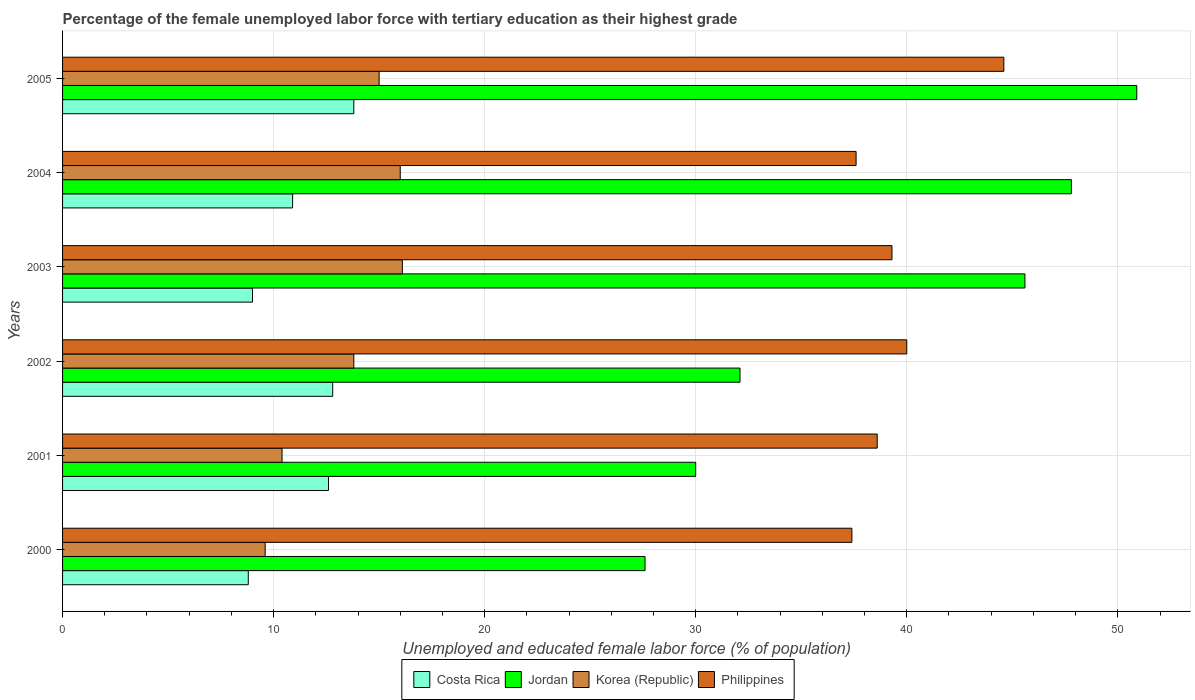How many different coloured bars are there?
Provide a short and direct response. 4. Are the number of bars per tick equal to the number of legend labels?
Your answer should be very brief. Yes. Are the number of bars on each tick of the Y-axis equal?
Your answer should be very brief. Yes. How many bars are there on the 4th tick from the top?
Keep it short and to the point. 4. How many bars are there on the 5th tick from the bottom?
Offer a very short reply. 4. What is the percentage of the unemployed female labor force with tertiary education in Philippines in 2003?
Your answer should be very brief. 39.3. Across all years, what is the maximum percentage of the unemployed female labor force with tertiary education in Korea (Republic)?
Ensure brevity in your answer.  16.1. Across all years, what is the minimum percentage of the unemployed female labor force with tertiary education in Korea (Republic)?
Ensure brevity in your answer.  9.6. In which year was the percentage of the unemployed female labor force with tertiary education in Philippines minimum?
Your answer should be compact. 2000. What is the total percentage of the unemployed female labor force with tertiary education in Korea (Republic) in the graph?
Keep it short and to the point. 80.9. What is the difference between the percentage of the unemployed female labor force with tertiary education in Costa Rica in 2001 and that in 2002?
Ensure brevity in your answer.  -0.2. What is the difference between the percentage of the unemployed female labor force with tertiary education in Jordan in 2003 and the percentage of the unemployed female labor force with tertiary education in Costa Rica in 2002?
Your response must be concise. 32.8. What is the average percentage of the unemployed female labor force with tertiary education in Costa Rica per year?
Provide a short and direct response. 11.32. In the year 2004, what is the difference between the percentage of the unemployed female labor force with tertiary education in Korea (Republic) and percentage of the unemployed female labor force with tertiary education in Costa Rica?
Offer a very short reply. 5.1. In how many years, is the percentage of the unemployed female labor force with tertiary education in Korea (Republic) greater than 20 %?
Give a very brief answer. 0. What is the ratio of the percentage of the unemployed female labor force with tertiary education in Jordan in 2003 to that in 2004?
Make the answer very short. 0.95. Is the percentage of the unemployed female labor force with tertiary education in Costa Rica in 2000 less than that in 2003?
Give a very brief answer. Yes. Is the difference between the percentage of the unemployed female labor force with tertiary education in Korea (Republic) in 2001 and 2005 greater than the difference between the percentage of the unemployed female labor force with tertiary education in Costa Rica in 2001 and 2005?
Offer a terse response. No. What is the difference between the highest and the second highest percentage of the unemployed female labor force with tertiary education in Jordan?
Your answer should be compact. 3.1. What is the difference between the highest and the lowest percentage of the unemployed female labor force with tertiary education in Costa Rica?
Ensure brevity in your answer.  5. Is the sum of the percentage of the unemployed female labor force with tertiary education in Korea (Republic) in 2001 and 2004 greater than the maximum percentage of the unemployed female labor force with tertiary education in Philippines across all years?
Offer a very short reply. No. Is it the case that in every year, the sum of the percentage of the unemployed female labor force with tertiary education in Philippines and percentage of the unemployed female labor force with tertiary education in Costa Rica is greater than the sum of percentage of the unemployed female labor force with tertiary education in Korea (Republic) and percentage of the unemployed female labor force with tertiary education in Jordan?
Offer a terse response. Yes. What does the 4th bar from the top in 2001 represents?
Give a very brief answer. Costa Rica. What does the 2nd bar from the bottom in 2000 represents?
Provide a succinct answer. Jordan. Are all the bars in the graph horizontal?
Keep it short and to the point. Yes. How many years are there in the graph?
Provide a succinct answer. 6. Are the values on the major ticks of X-axis written in scientific E-notation?
Keep it short and to the point. No. How many legend labels are there?
Offer a very short reply. 4. What is the title of the graph?
Offer a very short reply. Percentage of the female unemployed labor force with tertiary education as their highest grade. Does "Marshall Islands" appear as one of the legend labels in the graph?
Your answer should be very brief. No. What is the label or title of the X-axis?
Keep it short and to the point. Unemployed and educated female labor force (% of population). What is the label or title of the Y-axis?
Ensure brevity in your answer.  Years. What is the Unemployed and educated female labor force (% of population) of Costa Rica in 2000?
Ensure brevity in your answer.  8.8. What is the Unemployed and educated female labor force (% of population) of Jordan in 2000?
Your response must be concise. 27.6. What is the Unemployed and educated female labor force (% of population) of Korea (Republic) in 2000?
Offer a very short reply. 9.6. What is the Unemployed and educated female labor force (% of population) of Philippines in 2000?
Keep it short and to the point. 37.4. What is the Unemployed and educated female labor force (% of population) in Costa Rica in 2001?
Make the answer very short. 12.6. What is the Unemployed and educated female labor force (% of population) in Jordan in 2001?
Offer a terse response. 30. What is the Unemployed and educated female labor force (% of population) in Korea (Republic) in 2001?
Offer a very short reply. 10.4. What is the Unemployed and educated female labor force (% of population) in Philippines in 2001?
Provide a succinct answer. 38.6. What is the Unemployed and educated female labor force (% of population) of Costa Rica in 2002?
Offer a very short reply. 12.8. What is the Unemployed and educated female labor force (% of population) in Jordan in 2002?
Ensure brevity in your answer.  32.1. What is the Unemployed and educated female labor force (% of population) in Korea (Republic) in 2002?
Offer a terse response. 13.8. What is the Unemployed and educated female labor force (% of population) of Philippines in 2002?
Your response must be concise. 40. What is the Unemployed and educated female labor force (% of population) of Costa Rica in 2003?
Provide a succinct answer. 9. What is the Unemployed and educated female labor force (% of population) in Jordan in 2003?
Provide a short and direct response. 45.6. What is the Unemployed and educated female labor force (% of population) of Korea (Republic) in 2003?
Keep it short and to the point. 16.1. What is the Unemployed and educated female labor force (% of population) in Philippines in 2003?
Your response must be concise. 39.3. What is the Unemployed and educated female labor force (% of population) in Costa Rica in 2004?
Keep it short and to the point. 10.9. What is the Unemployed and educated female labor force (% of population) of Jordan in 2004?
Offer a very short reply. 47.8. What is the Unemployed and educated female labor force (% of population) of Philippines in 2004?
Your answer should be compact. 37.6. What is the Unemployed and educated female labor force (% of population) of Costa Rica in 2005?
Give a very brief answer. 13.8. What is the Unemployed and educated female labor force (% of population) in Jordan in 2005?
Give a very brief answer. 50.9. What is the Unemployed and educated female labor force (% of population) in Korea (Republic) in 2005?
Give a very brief answer. 15. What is the Unemployed and educated female labor force (% of population) of Philippines in 2005?
Keep it short and to the point. 44.6. Across all years, what is the maximum Unemployed and educated female labor force (% of population) of Costa Rica?
Keep it short and to the point. 13.8. Across all years, what is the maximum Unemployed and educated female labor force (% of population) in Jordan?
Provide a short and direct response. 50.9. Across all years, what is the maximum Unemployed and educated female labor force (% of population) in Korea (Republic)?
Ensure brevity in your answer.  16.1. Across all years, what is the maximum Unemployed and educated female labor force (% of population) of Philippines?
Offer a very short reply. 44.6. Across all years, what is the minimum Unemployed and educated female labor force (% of population) in Costa Rica?
Your answer should be very brief. 8.8. Across all years, what is the minimum Unemployed and educated female labor force (% of population) in Jordan?
Your answer should be very brief. 27.6. Across all years, what is the minimum Unemployed and educated female labor force (% of population) of Korea (Republic)?
Make the answer very short. 9.6. Across all years, what is the minimum Unemployed and educated female labor force (% of population) of Philippines?
Make the answer very short. 37.4. What is the total Unemployed and educated female labor force (% of population) of Costa Rica in the graph?
Your answer should be very brief. 67.9. What is the total Unemployed and educated female labor force (% of population) in Jordan in the graph?
Your answer should be compact. 234. What is the total Unemployed and educated female labor force (% of population) in Korea (Republic) in the graph?
Your response must be concise. 80.9. What is the total Unemployed and educated female labor force (% of population) in Philippines in the graph?
Keep it short and to the point. 237.5. What is the difference between the Unemployed and educated female labor force (% of population) of Costa Rica in 2000 and that in 2001?
Provide a short and direct response. -3.8. What is the difference between the Unemployed and educated female labor force (% of population) of Jordan in 2000 and that in 2001?
Make the answer very short. -2.4. What is the difference between the Unemployed and educated female labor force (% of population) in Korea (Republic) in 2000 and that in 2001?
Ensure brevity in your answer.  -0.8. What is the difference between the Unemployed and educated female labor force (% of population) in Philippines in 2000 and that in 2001?
Ensure brevity in your answer.  -1.2. What is the difference between the Unemployed and educated female labor force (% of population) of Costa Rica in 2000 and that in 2002?
Your response must be concise. -4. What is the difference between the Unemployed and educated female labor force (% of population) in Jordan in 2000 and that in 2002?
Keep it short and to the point. -4.5. What is the difference between the Unemployed and educated female labor force (% of population) in Korea (Republic) in 2000 and that in 2002?
Your answer should be very brief. -4.2. What is the difference between the Unemployed and educated female labor force (% of population) of Philippines in 2000 and that in 2002?
Give a very brief answer. -2.6. What is the difference between the Unemployed and educated female labor force (% of population) in Jordan in 2000 and that in 2003?
Your response must be concise. -18. What is the difference between the Unemployed and educated female labor force (% of population) of Philippines in 2000 and that in 2003?
Your answer should be very brief. -1.9. What is the difference between the Unemployed and educated female labor force (% of population) of Costa Rica in 2000 and that in 2004?
Offer a very short reply. -2.1. What is the difference between the Unemployed and educated female labor force (% of population) in Jordan in 2000 and that in 2004?
Provide a short and direct response. -20.2. What is the difference between the Unemployed and educated female labor force (% of population) in Jordan in 2000 and that in 2005?
Keep it short and to the point. -23.3. What is the difference between the Unemployed and educated female labor force (% of population) in Korea (Republic) in 2000 and that in 2005?
Provide a succinct answer. -5.4. What is the difference between the Unemployed and educated female labor force (% of population) of Philippines in 2000 and that in 2005?
Give a very brief answer. -7.2. What is the difference between the Unemployed and educated female labor force (% of population) of Jordan in 2001 and that in 2003?
Ensure brevity in your answer.  -15.6. What is the difference between the Unemployed and educated female labor force (% of population) of Korea (Republic) in 2001 and that in 2003?
Offer a very short reply. -5.7. What is the difference between the Unemployed and educated female labor force (% of population) in Costa Rica in 2001 and that in 2004?
Your answer should be compact. 1.7. What is the difference between the Unemployed and educated female labor force (% of population) of Jordan in 2001 and that in 2004?
Ensure brevity in your answer.  -17.8. What is the difference between the Unemployed and educated female labor force (% of population) of Korea (Republic) in 2001 and that in 2004?
Your answer should be compact. -5.6. What is the difference between the Unemployed and educated female labor force (% of population) of Costa Rica in 2001 and that in 2005?
Provide a succinct answer. -1.2. What is the difference between the Unemployed and educated female labor force (% of population) in Jordan in 2001 and that in 2005?
Ensure brevity in your answer.  -20.9. What is the difference between the Unemployed and educated female labor force (% of population) in Philippines in 2001 and that in 2005?
Provide a succinct answer. -6. What is the difference between the Unemployed and educated female labor force (% of population) in Costa Rica in 2002 and that in 2003?
Your answer should be compact. 3.8. What is the difference between the Unemployed and educated female labor force (% of population) of Korea (Republic) in 2002 and that in 2003?
Your response must be concise. -2.3. What is the difference between the Unemployed and educated female labor force (% of population) in Philippines in 2002 and that in 2003?
Your response must be concise. 0.7. What is the difference between the Unemployed and educated female labor force (% of population) of Jordan in 2002 and that in 2004?
Provide a short and direct response. -15.7. What is the difference between the Unemployed and educated female labor force (% of population) in Korea (Republic) in 2002 and that in 2004?
Your answer should be very brief. -2.2. What is the difference between the Unemployed and educated female labor force (% of population) in Philippines in 2002 and that in 2004?
Provide a short and direct response. 2.4. What is the difference between the Unemployed and educated female labor force (% of population) in Costa Rica in 2002 and that in 2005?
Offer a terse response. -1. What is the difference between the Unemployed and educated female labor force (% of population) of Jordan in 2002 and that in 2005?
Provide a short and direct response. -18.8. What is the difference between the Unemployed and educated female labor force (% of population) in Philippines in 2002 and that in 2005?
Offer a very short reply. -4.6. What is the difference between the Unemployed and educated female labor force (% of population) in Costa Rica in 2003 and that in 2004?
Offer a very short reply. -1.9. What is the difference between the Unemployed and educated female labor force (% of population) of Jordan in 2003 and that in 2004?
Offer a very short reply. -2.2. What is the difference between the Unemployed and educated female labor force (% of population) in Korea (Republic) in 2003 and that in 2005?
Ensure brevity in your answer.  1.1. What is the difference between the Unemployed and educated female labor force (% of population) of Philippines in 2003 and that in 2005?
Provide a succinct answer. -5.3. What is the difference between the Unemployed and educated female labor force (% of population) of Philippines in 2004 and that in 2005?
Make the answer very short. -7. What is the difference between the Unemployed and educated female labor force (% of population) in Costa Rica in 2000 and the Unemployed and educated female labor force (% of population) in Jordan in 2001?
Offer a terse response. -21.2. What is the difference between the Unemployed and educated female labor force (% of population) of Costa Rica in 2000 and the Unemployed and educated female labor force (% of population) of Korea (Republic) in 2001?
Your answer should be very brief. -1.6. What is the difference between the Unemployed and educated female labor force (% of population) of Costa Rica in 2000 and the Unemployed and educated female labor force (% of population) of Philippines in 2001?
Your response must be concise. -29.8. What is the difference between the Unemployed and educated female labor force (% of population) in Korea (Republic) in 2000 and the Unemployed and educated female labor force (% of population) in Philippines in 2001?
Offer a very short reply. -29. What is the difference between the Unemployed and educated female labor force (% of population) of Costa Rica in 2000 and the Unemployed and educated female labor force (% of population) of Jordan in 2002?
Keep it short and to the point. -23.3. What is the difference between the Unemployed and educated female labor force (% of population) in Costa Rica in 2000 and the Unemployed and educated female labor force (% of population) in Korea (Republic) in 2002?
Keep it short and to the point. -5. What is the difference between the Unemployed and educated female labor force (% of population) of Costa Rica in 2000 and the Unemployed and educated female labor force (% of population) of Philippines in 2002?
Provide a succinct answer. -31.2. What is the difference between the Unemployed and educated female labor force (% of population) in Korea (Republic) in 2000 and the Unemployed and educated female labor force (% of population) in Philippines in 2002?
Give a very brief answer. -30.4. What is the difference between the Unemployed and educated female labor force (% of population) of Costa Rica in 2000 and the Unemployed and educated female labor force (% of population) of Jordan in 2003?
Offer a terse response. -36.8. What is the difference between the Unemployed and educated female labor force (% of population) in Costa Rica in 2000 and the Unemployed and educated female labor force (% of population) in Philippines in 2003?
Provide a succinct answer. -30.5. What is the difference between the Unemployed and educated female labor force (% of population) in Jordan in 2000 and the Unemployed and educated female labor force (% of population) in Philippines in 2003?
Keep it short and to the point. -11.7. What is the difference between the Unemployed and educated female labor force (% of population) in Korea (Republic) in 2000 and the Unemployed and educated female labor force (% of population) in Philippines in 2003?
Provide a short and direct response. -29.7. What is the difference between the Unemployed and educated female labor force (% of population) in Costa Rica in 2000 and the Unemployed and educated female labor force (% of population) in Jordan in 2004?
Make the answer very short. -39. What is the difference between the Unemployed and educated female labor force (% of population) in Costa Rica in 2000 and the Unemployed and educated female labor force (% of population) in Korea (Republic) in 2004?
Your answer should be very brief. -7.2. What is the difference between the Unemployed and educated female labor force (% of population) of Costa Rica in 2000 and the Unemployed and educated female labor force (% of population) of Philippines in 2004?
Your response must be concise. -28.8. What is the difference between the Unemployed and educated female labor force (% of population) of Korea (Republic) in 2000 and the Unemployed and educated female labor force (% of population) of Philippines in 2004?
Your answer should be compact. -28. What is the difference between the Unemployed and educated female labor force (% of population) of Costa Rica in 2000 and the Unemployed and educated female labor force (% of population) of Jordan in 2005?
Provide a short and direct response. -42.1. What is the difference between the Unemployed and educated female labor force (% of population) in Costa Rica in 2000 and the Unemployed and educated female labor force (% of population) in Korea (Republic) in 2005?
Ensure brevity in your answer.  -6.2. What is the difference between the Unemployed and educated female labor force (% of population) of Costa Rica in 2000 and the Unemployed and educated female labor force (% of population) of Philippines in 2005?
Give a very brief answer. -35.8. What is the difference between the Unemployed and educated female labor force (% of population) in Jordan in 2000 and the Unemployed and educated female labor force (% of population) in Korea (Republic) in 2005?
Ensure brevity in your answer.  12.6. What is the difference between the Unemployed and educated female labor force (% of population) in Jordan in 2000 and the Unemployed and educated female labor force (% of population) in Philippines in 2005?
Keep it short and to the point. -17. What is the difference between the Unemployed and educated female labor force (% of population) in Korea (Republic) in 2000 and the Unemployed and educated female labor force (% of population) in Philippines in 2005?
Make the answer very short. -35. What is the difference between the Unemployed and educated female labor force (% of population) of Costa Rica in 2001 and the Unemployed and educated female labor force (% of population) of Jordan in 2002?
Ensure brevity in your answer.  -19.5. What is the difference between the Unemployed and educated female labor force (% of population) of Costa Rica in 2001 and the Unemployed and educated female labor force (% of population) of Korea (Republic) in 2002?
Keep it short and to the point. -1.2. What is the difference between the Unemployed and educated female labor force (% of population) in Costa Rica in 2001 and the Unemployed and educated female labor force (% of population) in Philippines in 2002?
Offer a terse response. -27.4. What is the difference between the Unemployed and educated female labor force (% of population) of Jordan in 2001 and the Unemployed and educated female labor force (% of population) of Philippines in 2002?
Offer a terse response. -10. What is the difference between the Unemployed and educated female labor force (% of population) in Korea (Republic) in 2001 and the Unemployed and educated female labor force (% of population) in Philippines in 2002?
Your answer should be compact. -29.6. What is the difference between the Unemployed and educated female labor force (% of population) in Costa Rica in 2001 and the Unemployed and educated female labor force (% of population) in Jordan in 2003?
Ensure brevity in your answer.  -33. What is the difference between the Unemployed and educated female labor force (% of population) in Costa Rica in 2001 and the Unemployed and educated female labor force (% of population) in Korea (Republic) in 2003?
Offer a very short reply. -3.5. What is the difference between the Unemployed and educated female labor force (% of population) of Costa Rica in 2001 and the Unemployed and educated female labor force (% of population) of Philippines in 2003?
Offer a very short reply. -26.7. What is the difference between the Unemployed and educated female labor force (% of population) of Korea (Republic) in 2001 and the Unemployed and educated female labor force (% of population) of Philippines in 2003?
Offer a terse response. -28.9. What is the difference between the Unemployed and educated female labor force (% of population) of Costa Rica in 2001 and the Unemployed and educated female labor force (% of population) of Jordan in 2004?
Offer a very short reply. -35.2. What is the difference between the Unemployed and educated female labor force (% of population) in Costa Rica in 2001 and the Unemployed and educated female labor force (% of population) in Korea (Republic) in 2004?
Offer a very short reply. -3.4. What is the difference between the Unemployed and educated female labor force (% of population) in Costa Rica in 2001 and the Unemployed and educated female labor force (% of population) in Philippines in 2004?
Give a very brief answer. -25. What is the difference between the Unemployed and educated female labor force (% of population) of Korea (Republic) in 2001 and the Unemployed and educated female labor force (% of population) of Philippines in 2004?
Provide a short and direct response. -27.2. What is the difference between the Unemployed and educated female labor force (% of population) of Costa Rica in 2001 and the Unemployed and educated female labor force (% of population) of Jordan in 2005?
Your answer should be compact. -38.3. What is the difference between the Unemployed and educated female labor force (% of population) of Costa Rica in 2001 and the Unemployed and educated female labor force (% of population) of Philippines in 2005?
Provide a short and direct response. -32. What is the difference between the Unemployed and educated female labor force (% of population) of Jordan in 2001 and the Unemployed and educated female labor force (% of population) of Philippines in 2005?
Keep it short and to the point. -14.6. What is the difference between the Unemployed and educated female labor force (% of population) of Korea (Republic) in 2001 and the Unemployed and educated female labor force (% of population) of Philippines in 2005?
Offer a terse response. -34.2. What is the difference between the Unemployed and educated female labor force (% of population) of Costa Rica in 2002 and the Unemployed and educated female labor force (% of population) of Jordan in 2003?
Make the answer very short. -32.8. What is the difference between the Unemployed and educated female labor force (% of population) of Costa Rica in 2002 and the Unemployed and educated female labor force (% of population) of Philippines in 2003?
Keep it short and to the point. -26.5. What is the difference between the Unemployed and educated female labor force (% of population) of Jordan in 2002 and the Unemployed and educated female labor force (% of population) of Korea (Republic) in 2003?
Offer a terse response. 16. What is the difference between the Unemployed and educated female labor force (% of population) in Jordan in 2002 and the Unemployed and educated female labor force (% of population) in Philippines in 2003?
Keep it short and to the point. -7.2. What is the difference between the Unemployed and educated female labor force (% of population) of Korea (Republic) in 2002 and the Unemployed and educated female labor force (% of population) of Philippines in 2003?
Your answer should be very brief. -25.5. What is the difference between the Unemployed and educated female labor force (% of population) of Costa Rica in 2002 and the Unemployed and educated female labor force (% of population) of Jordan in 2004?
Keep it short and to the point. -35. What is the difference between the Unemployed and educated female labor force (% of population) of Costa Rica in 2002 and the Unemployed and educated female labor force (% of population) of Philippines in 2004?
Your answer should be very brief. -24.8. What is the difference between the Unemployed and educated female labor force (% of population) of Jordan in 2002 and the Unemployed and educated female labor force (% of population) of Korea (Republic) in 2004?
Your answer should be very brief. 16.1. What is the difference between the Unemployed and educated female labor force (% of population) of Jordan in 2002 and the Unemployed and educated female labor force (% of population) of Philippines in 2004?
Give a very brief answer. -5.5. What is the difference between the Unemployed and educated female labor force (% of population) in Korea (Republic) in 2002 and the Unemployed and educated female labor force (% of population) in Philippines in 2004?
Provide a succinct answer. -23.8. What is the difference between the Unemployed and educated female labor force (% of population) of Costa Rica in 2002 and the Unemployed and educated female labor force (% of population) of Jordan in 2005?
Ensure brevity in your answer.  -38.1. What is the difference between the Unemployed and educated female labor force (% of population) of Costa Rica in 2002 and the Unemployed and educated female labor force (% of population) of Korea (Republic) in 2005?
Give a very brief answer. -2.2. What is the difference between the Unemployed and educated female labor force (% of population) of Costa Rica in 2002 and the Unemployed and educated female labor force (% of population) of Philippines in 2005?
Ensure brevity in your answer.  -31.8. What is the difference between the Unemployed and educated female labor force (% of population) in Korea (Republic) in 2002 and the Unemployed and educated female labor force (% of population) in Philippines in 2005?
Give a very brief answer. -30.8. What is the difference between the Unemployed and educated female labor force (% of population) in Costa Rica in 2003 and the Unemployed and educated female labor force (% of population) in Jordan in 2004?
Give a very brief answer. -38.8. What is the difference between the Unemployed and educated female labor force (% of population) of Costa Rica in 2003 and the Unemployed and educated female labor force (% of population) of Korea (Republic) in 2004?
Your answer should be very brief. -7. What is the difference between the Unemployed and educated female labor force (% of population) in Costa Rica in 2003 and the Unemployed and educated female labor force (% of population) in Philippines in 2004?
Your response must be concise. -28.6. What is the difference between the Unemployed and educated female labor force (% of population) of Jordan in 2003 and the Unemployed and educated female labor force (% of population) of Korea (Republic) in 2004?
Provide a short and direct response. 29.6. What is the difference between the Unemployed and educated female labor force (% of population) in Korea (Republic) in 2003 and the Unemployed and educated female labor force (% of population) in Philippines in 2004?
Your response must be concise. -21.5. What is the difference between the Unemployed and educated female labor force (% of population) of Costa Rica in 2003 and the Unemployed and educated female labor force (% of population) of Jordan in 2005?
Make the answer very short. -41.9. What is the difference between the Unemployed and educated female labor force (% of population) in Costa Rica in 2003 and the Unemployed and educated female labor force (% of population) in Philippines in 2005?
Make the answer very short. -35.6. What is the difference between the Unemployed and educated female labor force (% of population) in Jordan in 2003 and the Unemployed and educated female labor force (% of population) in Korea (Republic) in 2005?
Give a very brief answer. 30.6. What is the difference between the Unemployed and educated female labor force (% of population) of Jordan in 2003 and the Unemployed and educated female labor force (% of population) of Philippines in 2005?
Keep it short and to the point. 1. What is the difference between the Unemployed and educated female labor force (% of population) of Korea (Republic) in 2003 and the Unemployed and educated female labor force (% of population) of Philippines in 2005?
Keep it short and to the point. -28.5. What is the difference between the Unemployed and educated female labor force (% of population) of Costa Rica in 2004 and the Unemployed and educated female labor force (% of population) of Jordan in 2005?
Keep it short and to the point. -40. What is the difference between the Unemployed and educated female labor force (% of population) of Costa Rica in 2004 and the Unemployed and educated female labor force (% of population) of Korea (Republic) in 2005?
Give a very brief answer. -4.1. What is the difference between the Unemployed and educated female labor force (% of population) of Costa Rica in 2004 and the Unemployed and educated female labor force (% of population) of Philippines in 2005?
Your response must be concise. -33.7. What is the difference between the Unemployed and educated female labor force (% of population) of Jordan in 2004 and the Unemployed and educated female labor force (% of population) of Korea (Republic) in 2005?
Offer a terse response. 32.8. What is the difference between the Unemployed and educated female labor force (% of population) of Jordan in 2004 and the Unemployed and educated female labor force (% of population) of Philippines in 2005?
Provide a succinct answer. 3.2. What is the difference between the Unemployed and educated female labor force (% of population) in Korea (Republic) in 2004 and the Unemployed and educated female labor force (% of population) in Philippines in 2005?
Provide a short and direct response. -28.6. What is the average Unemployed and educated female labor force (% of population) in Costa Rica per year?
Keep it short and to the point. 11.32. What is the average Unemployed and educated female labor force (% of population) in Jordan per year?
Your answer should be compact. 39. What is the average Unemployed and educated female labor force (% of population) in Korea (Republic) per year?
Give a very brief answer. 13.48. What is the average Unemployed and educated female labor force (% of population) in Philippines per year?
Provide a short and direct response. 39.58. In the year 2000, what is the difference between the Unemployed and educated female labor force (% of population) in Costa Rica and Unemployed and educated female labor force (% of population) in Jordan?
Keep it short and to the point. -18.8. In the year 2000, what is the difference between the Unemployed and educated female labor force (% of population) of Costa Rica and Unemployed and educated female labor force (% of population) of Philippines?
Provide a short and direct response. -28.6. In the year 2000, what is the difference between the Unemployed and educated female labor force (% of population) in Jordan and Unemployed and educated female labor force (% of population) in Philippines?
Make the answer very short. -9.8. In the year 2000, what is the difference between the Unemployed and educated female labor force (% of population) in Korea (Republic) and Unemployed and educated female labor force (% of population) in Philippines?
Ensure brevity in your answer.  -27.8. In the year 2001, what is the difference between the Unemployed and educated female labor force (% of population) in Costa Rica and Unemployed and educated female labor force (% of population) in Jordan?
Your answer should be very brief. -17.4. In the year 2001, what is the difference between the Unemployed and educated female labor force (% of population) of Costa Rica and Unemployed and educated female labor force (% of population) of Korea (Republic)?
Give a very brief answer. 2.2. In the year 2001, what is the difference between the Unemployed and educated female labor force (% of population) in Costa Rica and Unemployed and educated female labor force (% of population) in Philippines?
Keep it short and to the point. -26. In the year 2001, what is the difference between the Unemployed and educated female labor force (% of population) of Jordan and Unemployed and educated female labor force (% of population) of Korea (Republic)?
Your response must be concise. 19.6. In the year 2001, what is the difference between the Unemployed and educated female labor force (% of population) of Jordan and Unemployed and educated female labor force (% of population) of Philippines?
Your answer should be very brief. -8.6. In the year 2001, what is the difference between the Unemployed and educated female labor force (% of population) of Korea (Republic) and Unemployed and educated female labor force (% of population) of Philippines?
Offer a very short reply. -28.2. In the year 2002, what is the difference between the Unemployed and educated female labor force (% of population) of Costa Rica and Unemployed and educated female labor force (% of population) of Jordan?
Provide a short and direct response. -19.3. In the year 2002, what is the difference between the Unemployed and educated female labor force (% of population) in Costa Rica and Unemployed and educated female labor force (% of population) in Philippines?
Make the answer very short. -27.2. In the year 2002, what is the difference between the Unemployed and educated female labor force (% of population) in Jordan and Unemployed and educated female labor force (% of population) in Philippines?
Your answer should be compact. -7.9. In the year 2002, what is the difference between the Unemployed and educated female labor force (% of population) in Korea (Republic) and Unemployed and educated female labor force (% of population) in Philippines?
Make the answer very short. -26.2. In the year 2003, what is the difference between the Unemployed and educated female labor force (% of population) in Costa Rica and Unemployed and educated female labor force (% of population) in Jordan?
Offer a very short reply. -36.6. In the year 2003, what is the difference between the Unemployed and educated female labor force (% of population) of Costa Rica and Unemployed and educated female labor force (% of population) of Korea (Republic)?
Make the answer very short. -7.1. In the year 2003, what is the difference between the Unemployed and educated female labor force (% of population) of Costa Rica and Unemployed and educated female labor force (% of population) of Philippines?
Your response must be concise. -30.3. In the year 2003, what is the difference between the Unemployed and educated female labor force (% of population) in Jordan and Unemployed and educated female labor force (% of population) in Korea (Republic)?
Ensure brevity in your answer.  29.5. In the year 2003, what is the difference between the Unemployed and educated female labor force (% of population) of Korea (Republic) and Unemployed and educated female labor force (% of population) of Philippines?
Your answer should be very brief. -23.2. In the year 2004, what is the difference between the Unemployed and educated female labor force (% of population) of Costa Rica and Unemployed and educated female labor force (% of population) of Jordan?
Your answer should be very brief. -36.9. In the year 2004, what is the difference between the Unemployed and educated female labor force (% of population) in Costa Rica and Unemployed and educated female labor force (% of population) in Korea (Republic)?
Offer a terse response. -5.1. In the year 2004, what is the difference between the Unemployed and educated female labor force (% of population) in Costa Rica and Unemployed and educated female labor force (% of population) in Philippines?
Ensure brevity in your answer.  -26.7. In the year 2004, what is the difference between the Unemployed and educated female labor force (% of population) of Jordan and Unemployed and educated female labor force (% of population) of Korea (Republic)?
Your answer should be very brief. 31.8. In the year 2004, what is the difference between the Unemployed and educated female labor force (% of population) of Jordan and Unemployed and educated female labor force (% of population) of Philippines?
Ensure brevity in your answer.  10.2. In the year 2004, what is the difference between the Unemployed and educated female labor force (% of population) of Korea (Republic) and Unemployed and educated female labor force (% of population) of Philippines?
Make the answer very short. -21.6. In the year 2005, what is the difference between the Unemployed and educated female labor force (% of population) of Costa Rica and Unemployed and educated female labor force (% of population) of Jordan?
Make the answer very short. -37.1. In the year 2005, what is the difference between the Unemployed and educated female labor force (% of population) of Costa Rica and Unemployed and educated female labor force (% of population) of Korea (Republic)?
Make the answer very short. -1.2. In the year 2005, what is the difference between the Unemployed and educated female labor force (% of population) of Costa Rica and Unemployed and educated female labor force (% of population) of Philippines?
Offer a very short reply. -30.8. In the year 2005, what is the difference between the Unemployed and educated female labor force (% of population) of Jordan and Unemployed and educated female labor force (% of population) of Korea (Republic)?
Provide a short and direct response. 35.9. In the year 2005, what is the difference between the Unemployed and educated female labor force (% of population) in Korea (Republic) and Unemployed and educated female labor force (% of population) in Philippines?
Provide a short and direct response. -29.6. What is the ratio of the Unemployed and educated female labor force (% of population) of Costa Rica in 2000 to that in 2001?
Provide a short and direct response. 0.7. What is the ratio of the Unemployed and educated female labor force (% of population) in Philippines in 2000 to that in 2001?
Provide a short and direct response. 0.97. What is the ratio of the Unemployed and educated female labor force (% of population) in Costa Rica in 2000 to that in 2002?
Offer a very short reply. 0.69. What is the ratio of the Unemployed and educated female labor force (% of population) of Jordan in 2000 to that in 2002?
Make the answer very short. 0.86. What is the ratio of the Unemployed and educated female labor force (% of population) of Korea (Republic) in 2000 to that in 2002?
Provide a succinct answer. 0.7. What is the ratio of the Unemployed and educated female labor force (% of population) in Philippines in 2000 to that in 2002?
Ensure brevity in your answer.  0.94. What is the ratio of the Unemployed and educated female labor force (% of population) of Costa Rica in 2000 to that in 2003?
Provide a succinct answer. 0.98. What is the ratio of the Unemployed and educated female labor force (% of population) of Jordan in 2000 to that in 2003?
Make the answer very short. 0.61. What is the ratio of the Unemployed and educated female labor force (% of population) in Korea (Republic) in 2000 to that in 2003?
Make the answer very short. 0.6. What is the ratio of the Unemployed and educated female labor force (% of population) of Philippines in 2000 to that in 2003?
Provide a succinct answer. 0.95. What is the ratio of the Unemployed and educated female labor force (% of population) of Costa Rica in 2000 to that in 2004?
Make the answer very short. 0.81. What is the ratio of the Unemployed and educated female labor force (% of population) of Jordan in 2000 to that in 2004?
Make the answer very short. 0.58. What is the ratio of the Unemployed and educated female labor force (% of population) of Costa Rica in 2000 to that in 2005?
Keep it short and to the point. 0.64. What is the ratio of the Unemployed and educated female labor force (% of population) in Jordan in 2000 to that in 2005?
Provide a short and direct response. 0.54. What is the ratio of the Unemployed and educated female labor force (% of population) in Korea (Republic) in 2000 to that in 2005?
Ensure brevity in your answer.  0.64. What is the ratio of the Unemployed and educated female labor force (% of population) in Philippines in 2000 to that in 2005?
Ensure brevity in your answer.  0.84. What is the ratio of the Unemployed and educated female labor force (% of population) in Costa Rica in 2001 to that in 2002?
Your answer should be compact. 0.98. What is the ratio of the Unemployed and educated female labor force (% of population) in Jordan in 2001 to that in 2002?
Your response must be concise. 0.93. What is the ratio of the Unemployed and educated female labor force (% of population) in Korea (Republic) in 2001 to that in 2002?
Offer a very short reply. 0.75. What is the ratio of the Unemployed and educated female labor force (% of population) of Jordan in 2001 to that in 2003?
Provide a succinct answer. 0.66. What is the ratio of the Unemployed and educated female labor force (% of population) in Korea (Republic) in 2001 to that in 2003?
Offer a terse response. 0.65. What is the ratio of the Unemployed and educated female labor force (% of population) in Philippines in 2001 to that in 2003?
Give a very brief answer. 0.98. What is the ratio of the Unemployed and educated female labor force (% of population) of Costa Rica in 2001 to that in 2004?
Offer a very short reply. 1.16. What is the ratio of the Unemployed and educated female labor force (% of population) of Jordan in 2001 to that in 2004?
Your response must be concise. 0.63. What is the ratio of the Unemployed and educated female labor force (% of population) in Korea (Republic) in 2001 to that in 2004?
Your response must be concise. 0.65. What is the ratio of the Unemployed and educated female labor force (% of population) in Philippines in 2001 to that in 2004?
Your response must be concise. 1.03. What is the ratio of the Unemployed and educated female labor force (% of population) of Costa Rica in 2001 to that in 2005?
Give a very brief answer. 0.91. What is the ratio of the Unemployed and educated female labor force (% of population) of Jordan in 2001 to that in 2005?
Keep it short and to the point. 0.59. What is the ratio of the Unemployed and educated female labor force (% of population) of Korea (Republic) in 2001 to that in 2005?
Ensure brevity in your answer.  0.69. What is the ratio of the Unemployed and educated female labor force (% of population) in Philippines in 2001 to that in 2005?
Ensure brevity in your answer.  0.87. What is the ratio of the Unemployed and educated female labor force (% of population) in Costa Rica in 2002 to that in 2003?
Your answer should be very brief. 1.42. What is the ratio of the Unemployed and educated female labor force (% of population) in Jordan in 2002 to that in 2003?
Make the answer very short. 0.7. What is the ratio of the Unemployed and educated female labor force (% of population) of Korea (Republic) in 2002 to that in 2003?
Keep it short and to the point. 0.86. What is the ratio of the Unemployed and educated female labor force (% of population) in Philippines in 2002 to that in 2003?
Make the answer very short. 1.02. What is the ratio of the Unemployed and educated female labor force (% of population) of Costa Rica in 2002 to that in 2004?
Make the answer very short. 1.17. What is the ratio of the Unemployed and educated female labor force (% of population) of Jordan in 2002 to that in 2004?
Offer a very short reply. 0.67. What is the ratio of the Unemployed and educated female labor force (% of population) of Korea (Republic) in 2002 to that in 2004?
Your answer should be compact. 0.86. What is the ratio of the Unemployed and educated female labor force (% of population) in Philippines in 2002 to that in 2004?
Provide a short and direct response. 1.06. What is the ratio of the Unemployed and educated female labor force (% of population) in Costa Rica in 2002 to that in 2005?
Ensure brevity in your answer.  0.93. What is the ratio of the Unemployed and educated female labor force (% of population) in Jordan in 2002 to that in 2005?
Give a very brief answer. 0.63. What is the ratio of the Unemployed and educated female labor force (% of population) in Korea (Republic) in 2002 to that in 2005?
Make the answer very short. 0.92. What is the ratio of the Unemployed and educated female labor force (% of population) of Philippines in 2002 to that in 2005?
Offer a very short reply. 0.9. What is the ratio of the Unemployed and educated female labor force (% of population) of Costa Rica in 2003 to that in 2004?
Provide a short and direct response. 0.83. What is the ratio of the Unemployed and educated female labor force (% of population) of Jordan in 2003 to that in 2004?
Keep it short and to the point. 0.95. What is the ratio of the Unemployed and educated female labor force (% of population) of Korea (Republic) in 2003 to that in 2004?
Ensure brevity in your answer.  1.01. What is the ratio of the Unemployed and educated female labor force (% of population) of Philippines in 2003 to that in 2004?
Your response must be concise. 1.05. What is the ratio of the Unemployed and educated female labor force (% of population) in Costa Rica in 2003 to that in 2005?
Offer a terse response. 0.65. What is the ratio of the Unemployed and educated female labor force (% of population) in Jordan in 2003 to that in 2005?
Your answer should be very brief. 0.9. What is the ratio of the Unemployed and educated female labor force (% of population) in Korea (Republic) in 2003 to that in 2005?
Your answer should be very brief. 1.07. What is the ratio of the Unemployed and educated female labor force (% of population) of Philippines in 2003 to that in 2005?
Provide a succinct answer. 0.88. What is the ratio of the Unemployed and educated female labor force (% of population) in Costa Rica in 2004 to that in 2005?
Your response must be concise. 0.79. What is the ratio of the Unemployed and educated female labor force (% of population) in Jordan in 2004 to that in 2005?
Offer a terse response. 0.94. What is the ratio of the Unemployed and educated female labor force (% of population) of Korea (Republic) in 2004 to that in 2005?
Your response must be concise. 1.07. What is the ratio of the Unemployed and educated female labor force (% of population) in Philippines in 2004 to that in 2005?
Provide a succinct answer. 0.84. What is the difference between the highest and the second highest Unemployed and educated female labor force (% of population) of Korea (Republic)?
Your answer should be compact. 0.1. What is the difference between the highest and the second highest Unemployed and educated female labor force (% of population) in Philippines?
Your answer should be compact. 4.6. What is the difference between the highest and the lowest Unemployed and educated female labor force (% of population) in Jordan?
Provide a short and direct response. 23.3. 